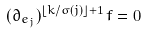<formula> <loc_0><loc_0><loc_500><loc_500>( \partial _ { e _ { j } } ) ^ { \lfloor k / \sigma ( j ) \rfloor + 1 } f = 0</formula> 